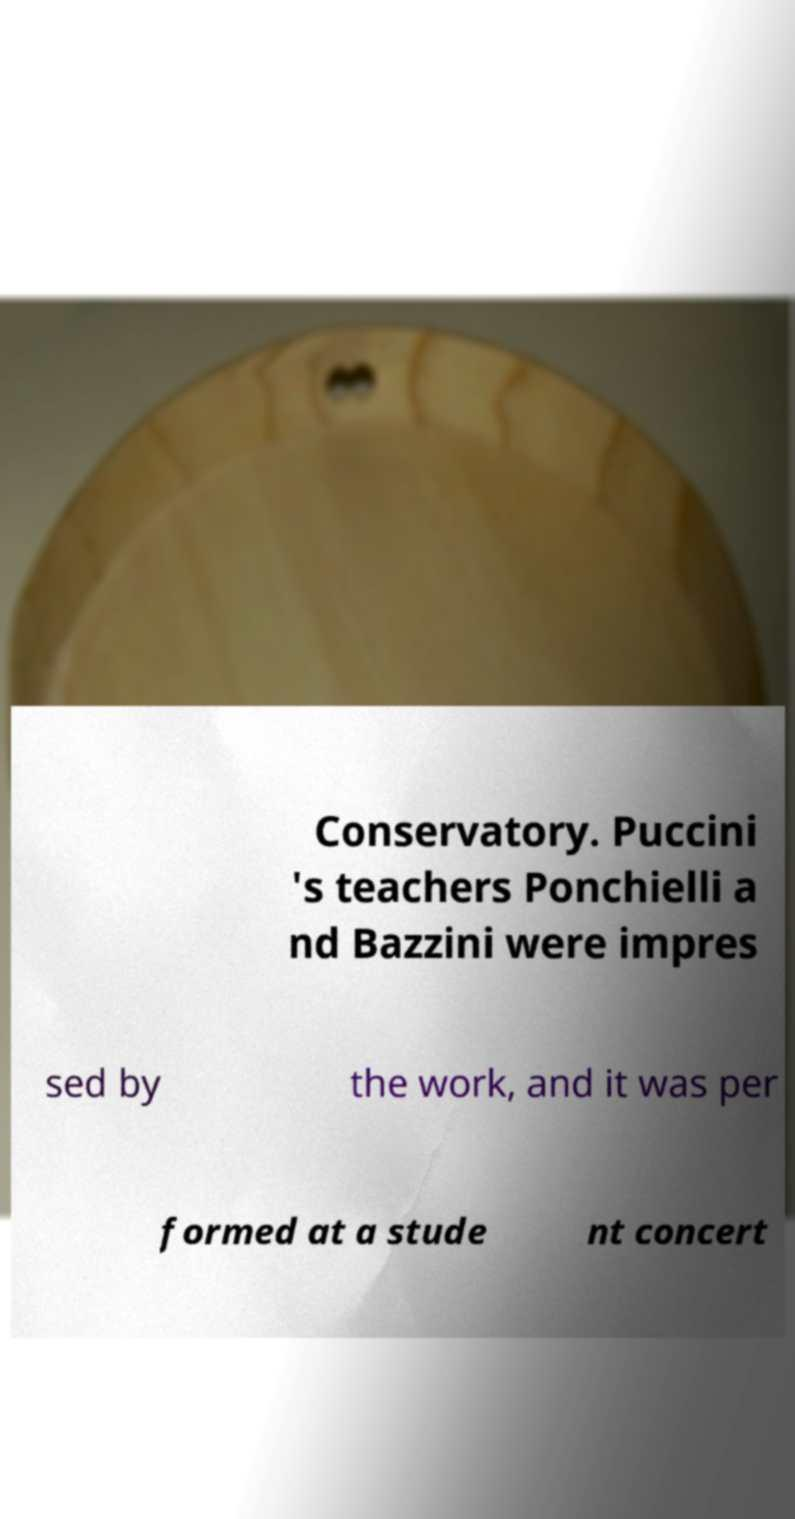Could you extract and type out the text from this image? Conservatory. Puccini 's teachers Ponchielli a nd Bazzini were impres sed by the work, and it was per formed at a stude nt concert 